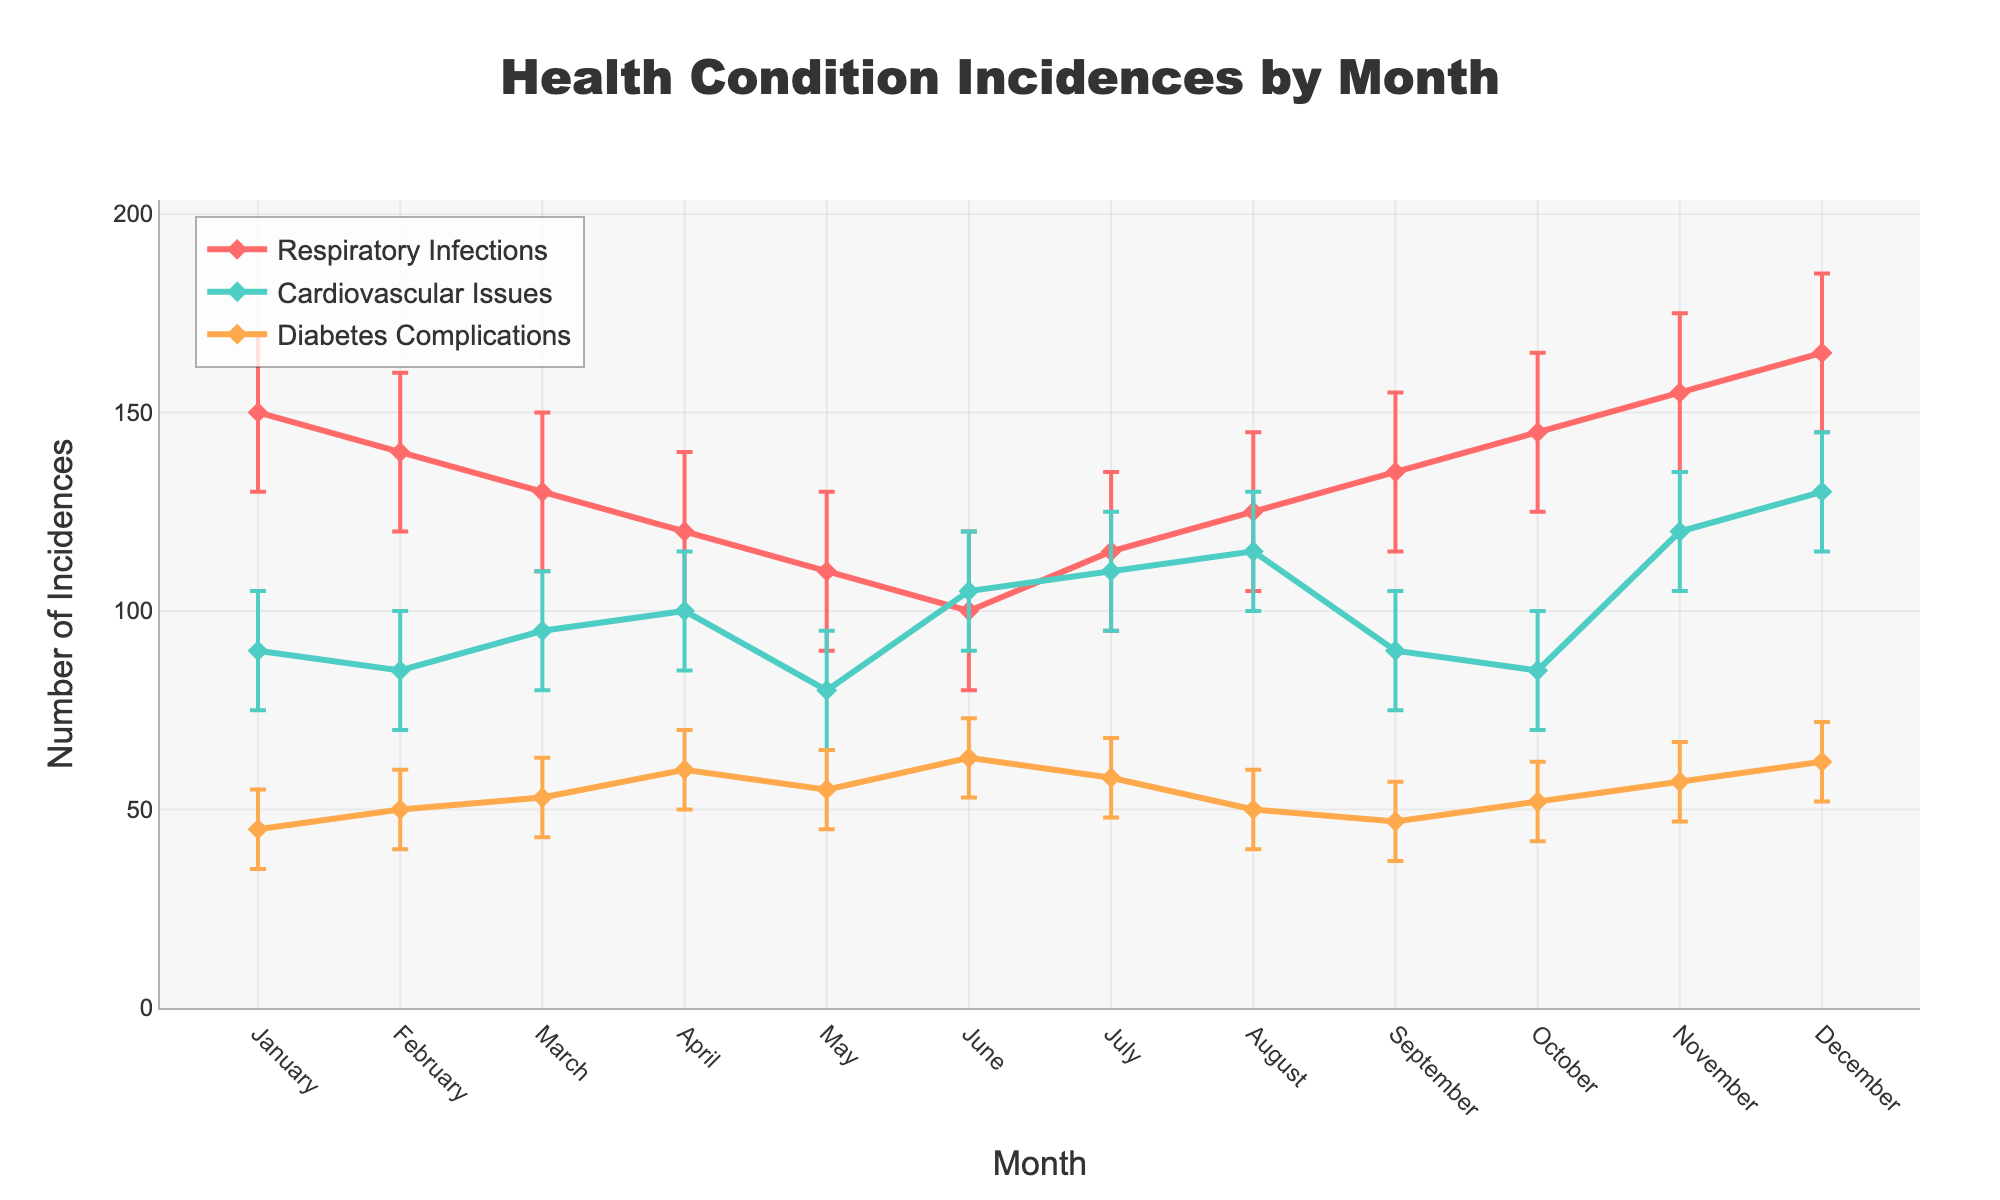What is the title of the plot? The title of the plot is prominently displayed at the top center of the figure. It reads "Health Condition Incidences by Month".
Answer: Health Condition Incidences by Month What are the three health conditions presented in the plot? The legend on the top right of the plot shows three colored labels corresponding to the health conditions: Respiratory Infections, Cardiovascular Issues, and Diabetes Complications.
Answer: Respiratory Infections, Cardiovascular Issues, Diabetes Complications In which month did Respiratory Infections have the highest mean incidence? By examining the line for Respiratory Infections, the highest point on the y-axis occurs in December, indicating the highest mean incidence of Respiratory Infections.
Answer: December What are the upper bounds of the confidence intervals for Cardiovascular Issues in July and November? For July, the line plot with error bars and the data point of Cardiovascular Issues shows the upper bound at 125. For November, the upper bound is indicated at 135.
Answer: 125, 135 Which health condition shows the most variability in monthly incidences? The length of the error bars represents variability. By comparing the error bars across all conditions, Respiratory Infections consistently have larger error bars, indicating greater variability.
Answer: Respiratory Infections How many months have a mean incidence of Cardiovascular Issues below 100? By observing the line plot for Cardiovascular Issues, the segments below the 100 incidence line correspond to January, February, May, September, and October. Thus, there are 5 months below 100.
Answer: 5 Which month shows an equal or higher incidence of Diabetes Complications than February? Comparing the Diabetes Complications line for February (mean incidence = 50), the months with equal or higher incidences are March, April, May, June, July, November, and December.
Answer: March, April, May, June, July, November, December What is the difference between the highest and the lowest monthly mean incidences for Respiratory Infections? The highest mean incidence for Respiratory Infections is in December at 165. The lowest is in June at 100. Subtracting the lowest from the highest: 165 - 100 = 65.
Answer: 65 Which health condition has the highest mean incidence in November, and what is that value? Observing the graphs for all conditions in November, Respiratory Infections have the highest mean incidence at 155.
Answer: Respiratory Infections, 155 